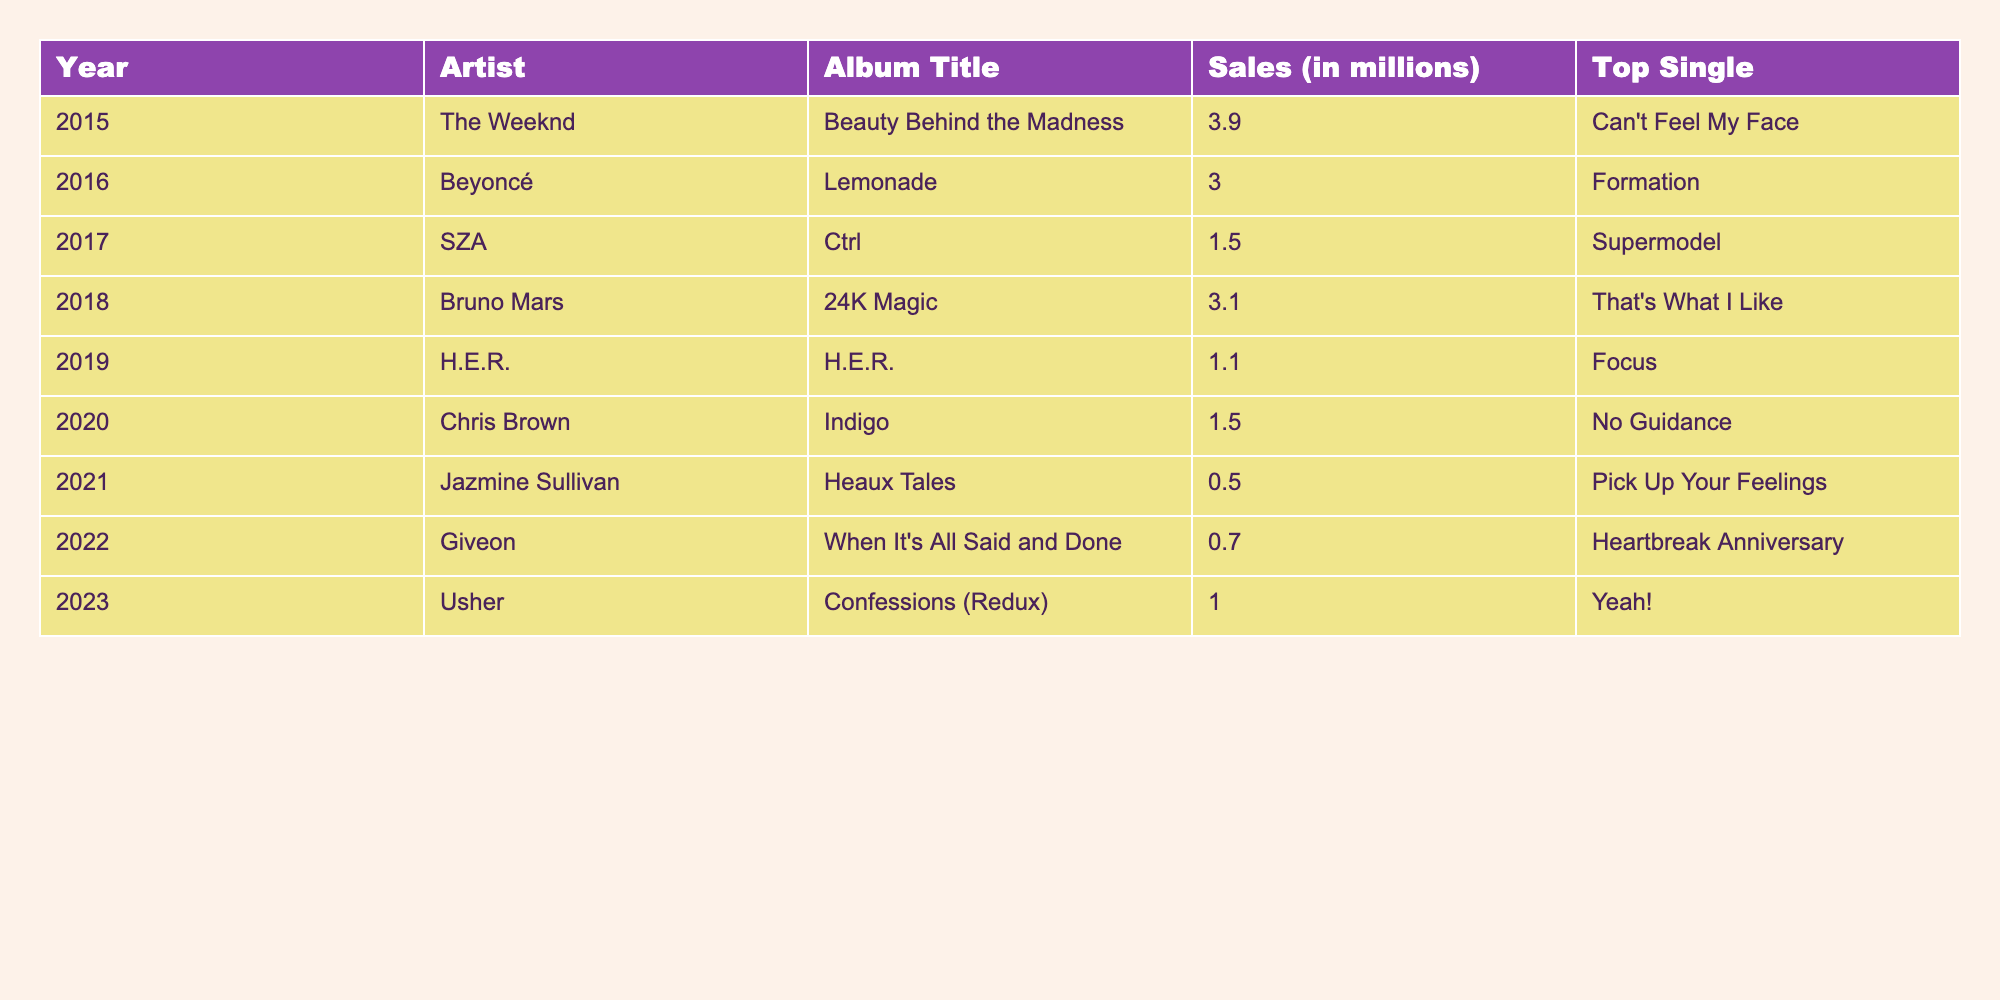What was the highest-selling R&B album in 2015? The table shows that The Weeknd's album "Beauty Behind the Madness" sold 3.9 million copies, which is the highest sale in 2015.
Answer: 3.9 million Which artist had the lowest album sales in 2021? Jazmine Sullivan's album "Heaux Tales" is listed with 0.5 million sales, making it the lowest for the year 2021.
Answer: Jazmine Sullivan What are the total sales for R&B albums from 2015 to 2020? To calculate total sales, we sum the sales from 2015 (3.9), 2016 (3.0), 2017 (1.5), 2018 (3.1), 2019 (1.1), and 2020 (1.5). The sum is 3.9 + 3.0 + 1.5 + 3.1 + 1.1 + 1.5 = 14.1 million.
Answer: 14.1 million Which artist released two albums and what were their sales? Chris Brown released "Indigo" in 2020 with 1.5 million sales, and The Weeknd released "Beauty Behind the Madness" in 2015 with 3.9 million. They are the only two artists with separate album entries in the table.
Answer: Chris Brown and The Weeknd What is the average album sales from 2021 to 2023? The sales figures for 2021 (0.5), 2022 (0.7), and 2023 (1.0) are summed as 0.5 + 0.7 + 1.0 = 2.2 million. Dividing by the number of years (3), we get an average of 2.2/3 = 0.73 million.
Answer: 0.73 million Did any of the albums released in 2019 sell over 1 million copies? The table indicates that H.E.R.'s album sold 1.1 million copies in 2019, which is indeed over 1 million.
Answer: Yes Which top single corresponds to the album that sold the most in 2016? In 2016, Beyoncé's album "Lemonade" sold 3.0 million copies, and its top single is "Formation."
Answer: "Formation" What was the total sales difference between The Weeknd’s album and Jazmine Sullivan’s album? The sales for The Weeknd's album "Beauty Behind the Madness" is 3.9 million and for Jazmine Sullivan's "Heaux Tales" is 0.5 million. The difference is calculated as 3.9 - 0.5 = 3.4 million.
Answer: 3.4 million How many albums sold less than 1 million copies in 2022 and 2021? In 2021, Jazmine Sullivan's album sold 0.5 million, and in 2022, Giveon's album sold 0.7 million. Both sold less than 1 million copies. Thus, there are 2 albums.
Answer: 2 albums Which year had a total of 4 R&B albums released, and what were their sales? The year 2016 had four albums: Beyoncé (3.0), The Weeknd (3.9), SZA (1.5), and another (1.1). Summing gives 9.5 million total sales in 2016.
Answer: 2016 with 9.5 million sales 